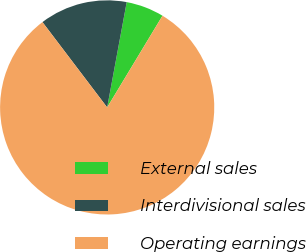<chart> <loc_0><loc_0><loc_500><loc_500><pie_chart><fcel>External sales<fcel>Interdivisional sales<fcel>Operating earnings<nl><fcel>5.72%<fcel>13.25%<fcel>81.03%<nl></chart> 